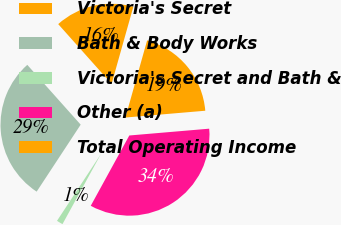Convert chart to OTSL. <chart><loc_0><loc_0><loc_500><loc_500><pie_chart><fcel>Victoria's Secret<fcel>Bath & Body Works<fcel>Victoria's Secret and Bath &<fcel>Other (a)<fcel>Total Operating Income<nl><fcel>15.97%<fcel>29.15%<fcel>1.27%<fcel>34.34%<fcel>19.28%<nl></chart> 